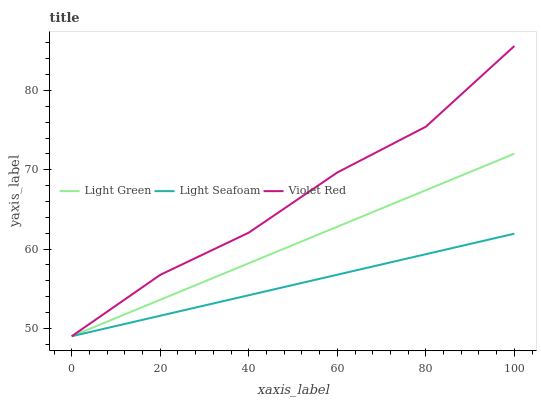Does Light Green have the minimum area under the curve?
Answer yes or no. No. Does Light Green have the maximum area under the curve?
Answer yes or no. No. Is Light Seafoam the smoothest?
Answer yes or no. No. Is Light Seafoam the roughest?
Answer yes or no. No. Does Light Green have the highest value?
Answer yes or no. No. 